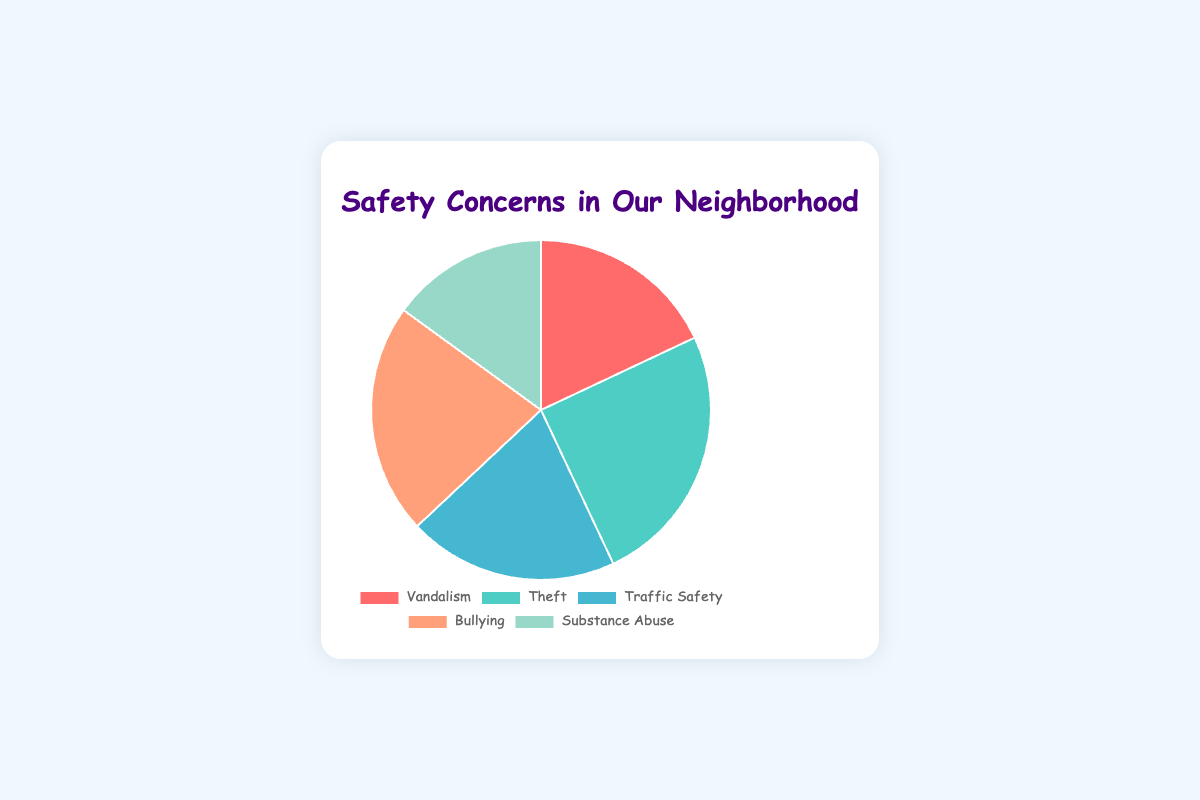What is the total percentage of concerns addressed in the chart? Adding up all the data points: (18 + 25 + 20 + 22 + 15) = 100, so the total percentage is 100%.
Answer: 100% Which concern has the highest percentage in the pie chart? The data point with the highest value is Theft, which is 25%.
Answer: Theft What is the difference in percentage between Bullying and Substance Abuse? Subtract Substance Abuse's percentage from Bullying's percentage: 22% - 15% = 7%.
Answer: 7% How does the percentage of Traffic Safety compare to Vandalism? Traffic Safety is at 20% while Vandalism is at 18%. Traffic Safety's percentage is higher.
Answer: Traffic Safety is higher What is the sum of the percentages for Vandalism and Theft concerns? Adding Vandalism (18%) and Theft (25%): 18% + 25% = 43%.
Answer: 43% Which concern is represented by the color red in the pie chart? The red segment of the pie chart corresponds to Vandalism.
Answer: Vandalism How many concerns have a percentage greater than 20%? The concerns with percentages greater than 20% are Theft (25%) and Bullying (22%). Therefore, 2 concerns.
Answer: 2 Is Substance Abuse represented by a percentage less than 20%? Substance Abuse has a percentage of 15%, which is indeed less than 20%.
Answer: Yes What is the average percentage of all the safety concerns displayed in the chart? Adding all the percentages: (18 + 25 + 20 + 22 + 15) = 100, and then dividing by the number of concerns: 100 / 5 = 20%.
Answer: 20% 